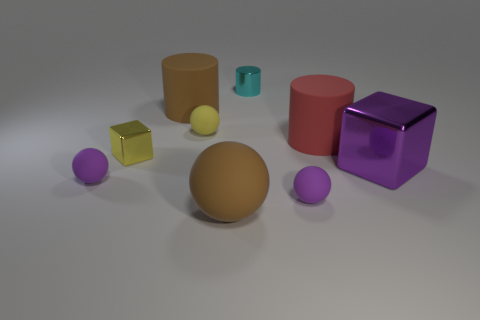What number of cyan objects have the same material as the brown ball?
Provide a short and direct response. 0. There is a small block; is its color the same as the small sphere behind the big metal cube?
Offer a terse response. Yes. What color is the tiny metal object that is right of the yellow thing that is in front of the red rubber cylinder?
Your answer should be very brief. Cyan. There is a metallic cube that is the same size as the cyan shiny cylinder; what is its color?
Your answer should be compact. Yellow. Is there another metal object of the same shape as the big red thing?
Offer a terse response. Yes. There is a red matte thing; what shape is it?
Offer a terse response. Cylinder. Are there more small metallic cubes left of the tiny cylinder than red objects in front of the large block?
Your answer should be compact. Yes. How many other things are the same size as the metal cylinder?
Your answer should be very brief. 4. There is a big thing that is both in front of the red rubber object and on the right side of the tiny cyan cylinder; what material is it?
Your response must be concise. Metal. There is a yellow object that is the same shape as the purple metal thing; what is it made of?
Your answer should be compact. Metal. 